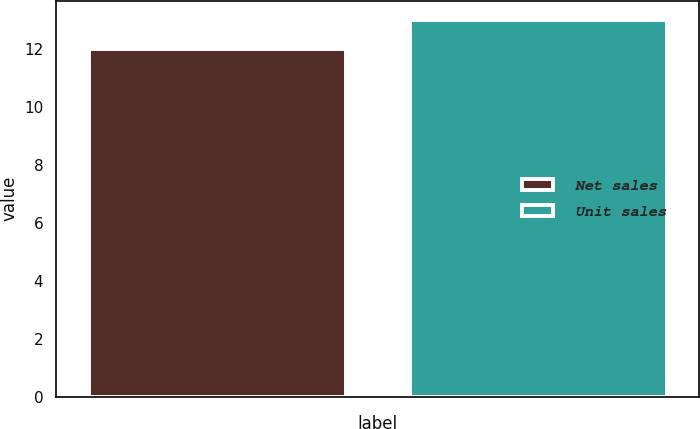<chart> <loc_0><loc_0><loc_500><loc_500><bar_chart><fcel>Net sales<fcel>Unit sales<nl><fcel>12<fcel>13<nl></chart> 